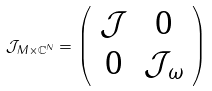<formula> <loc_0><loc_0><loc_500><loc_500>\mathcal { J } _ { M \times \mathbb { C } ^ { N } } = \left ( \begin{array} { c c c } \mathcal { J } & 0 \\ 0 & \mathcal { J } _ { \omega } \\ \end{array} \right )</formula> 